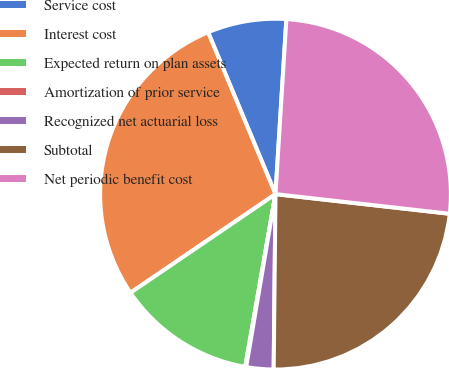<chart> <loc_0><loc_0><loc_500><loc_500><pie_chart><fcel>Service cost<fcel>Interest cost<fcel>Expected return on plan assets<fcel>Amortization of prior service<fcel>Recognized net actuarial loss<fcel>Subtotal<fcel>Net periodic benefit cost<nl><fcel>7.27%<fcel>28.23%<fcel>12.73%<fcel>0.09%<fcel>2.51%<fcel>23.38%<fcel>25.8%<nl></chart> 